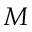Convert formula to latex. <formula><loc_0><loc_0><loc_500><loc_500>M</formula> 